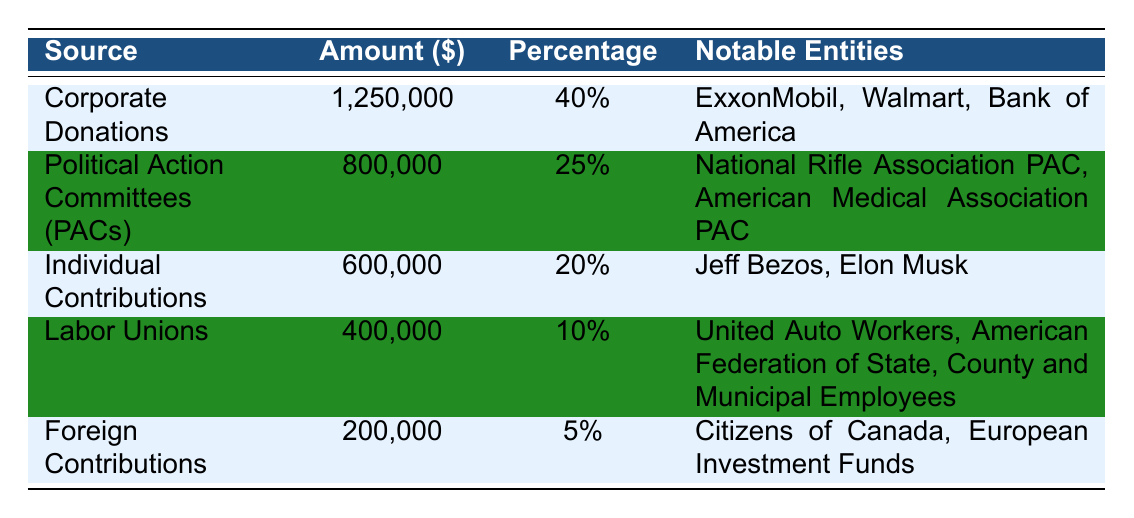What is the source with the highest amount of campaign finance contributions? The table lists the sources of contributions along with their respective amounts. By examining the amounts, Corporate Donations is identified as the source with the highest amount, totaling 1,250,000 dollars.
Answer: Corporate Donations What percentage of total contributions comes from Labor Unions? The table shows that Labor Unions contribute 400,000 dollars, which is 10 percent of the total contributions.
Answer: 10% Which two notable entities are associated with Political Action Committees? The table under the Political Action Committees row lists the notable entities as the National Rifle Association PAC and the American Medical Association PAC.
Answer: National Rifle Association PAC, American Medical Association PAC What is the total amount contributed by Corporate Donations and Individual Contributions combined? The amounts for Corporate Donations and Individual Contributions are 1,250,000 and 600,000 respectively. Adding these two amounts gives 1,250,000 + 600,000 = 1,850,000 dollars.
Answer: 1,850,000 Are Foreign Contributions greater than contributions from Labor Unions? The table shows that Foreign Contributions total 200,000 dollars, while Labor Unions contribute 400,000 dollars. Since 200,000 is less than 400,000, the statement is false.
Answer: No What is the combined percentage of contributions from Political Action Committees and Labor Unions? From the table, Political Action Committees contribute 25 percent and Labor Unions contribute 10 percent. Adding these gives 25 + 10 = 35 percent.
Answer: 35% Is it true that the majority of contributions come from Individual Contributions? Individual Contributions make up 20 percent of the total contributions. The highest percentage of contributions is from Corporate Donations at 40 percent. Therefore, it is false that Individual Contributions are the majority.
Answer: No What is the difference between the amounts contributed by Corporate Donations and Foreign Contributions? Corporate Donations amount to 1,250,000 dollars and Foreign Contributions total 200,000 dollars. The difference is calculated as 1,250,000 - 200,000 = 1,050,000 dollars.
Answer: 1,050,000 